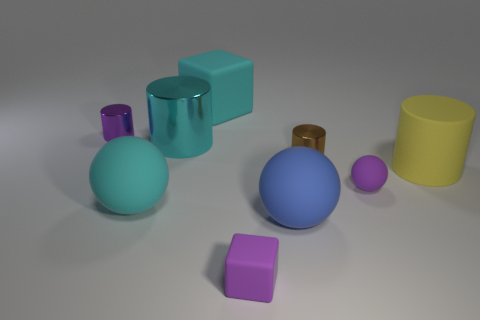What is the color of the small thing right of the tiny brown thing?
Provide a short and direct response. Purple. How many purple objects are small cylinders or cylinders?
Offer a very short reply. 1. The tiny matte block is what color?
Give a very brief answer. Purple. Is there any other thing that is the same material as the yellow thing?
Offer a very short reply. Yes. Are there fewer large cubes in front of the big cyan cube than small brown cylinders that are behind the purple metallic thing?
Your answer should be very brief. No. There is a object that is right of the brown shiny object and on the left side of the yellow rubber object; what shape is it?
Offer a terse response. Sphere. What number of purple rubber objects have the same shape as the blue rubber object?
Keep it short and to the point. 1. What is the size of the purple object that is made of the same material as the small brown cylinder?
Offer a terse response. Small. What number of cyan shiny things are the same size as the cyan cube?
Keep it short and to the point. 1. There is a matte cube that is the same color as the tiny rubber ball; what size is it?
Your answer should be very brief. Small. 